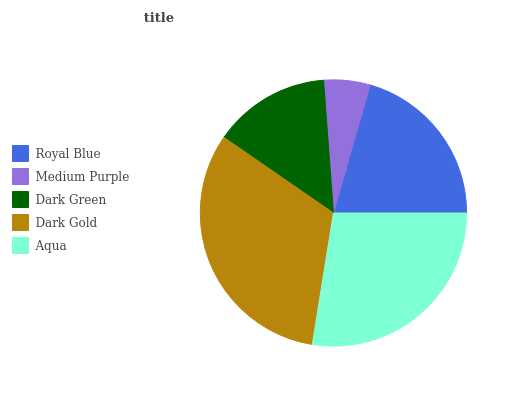Is Medium Purple the minimum?
Answer yes or no. Yes. Is Dark Gold the maximum?
Answer yes or no. Yes. Is Dark Green the minimum?
Answer yes or no. No. Is Dark Green the maximum?
Answer yes or no. No. Is Dark Green greater than Medium Purple?
Answer yes or no. Yes. Is Medium Purple less than Dark Green?
Answer yes or no. Yes. Is Medium Purple greater than Dark Green?
Answer yes or no. No. Is Dark Green less than Medium Purple?
Answer yes or no. No. Is Royal Blue the high median?
Answer yes or no. Yes. Is Royal Blue the low median?
Answer yes or no. Yes. Is Aqua the high median?
Answer yes or no. No. Is Dark Green the low median?
Answer yes or no. No. 